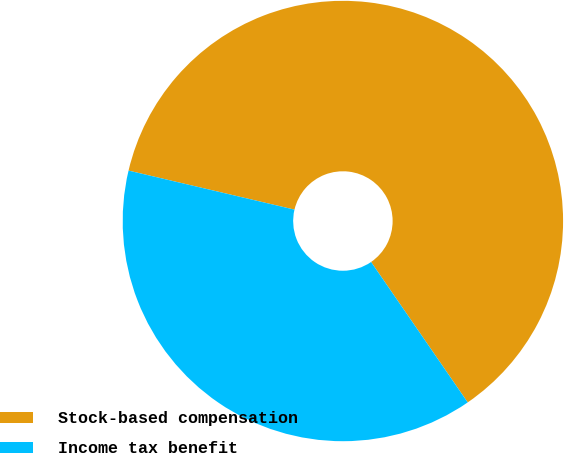<chart> <loc_0><loc_0><loc_500><loc_500><pie_chart><fcel>Stock-based compensation<fcel>Income tax benefit<nl><fcel>61.73%<fcel>38.27%<nl></chart> 